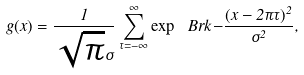Convert formula to latex. <formula><loc_0><loc_0><loc_500><loc_500>g ( x ) = \frac { 1 } { \sqrt { \pi } \sigma } \sum _ { \tau = - \infty } ^ { \infty } \exp \ B r k { - \frac { ( x - 2 \pi \tau ) ^ { 2 } } { \sigma ^ { 2 } } } ,</formula> 